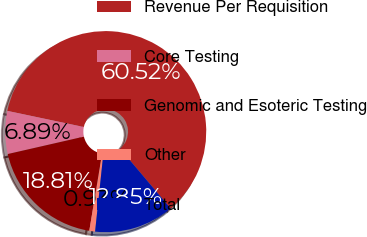Convert chart. <chart><loc_0><loc_0><loc_500><loc_500><pie_chart><fcel>Revenue Per Requisition<fcel>Core Testing<fcel>Genomic and Esoteric Testing<fcel>Other<fcel>Total<nl><fcel>60.53%<fcel>6.89%<fcel>18.81%<fcel>0.93%<fcel>12.85%<nl></chart> 